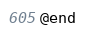<code> <loc_0><loc_0><loc_500><loc_500><_C_>@end

</code> 